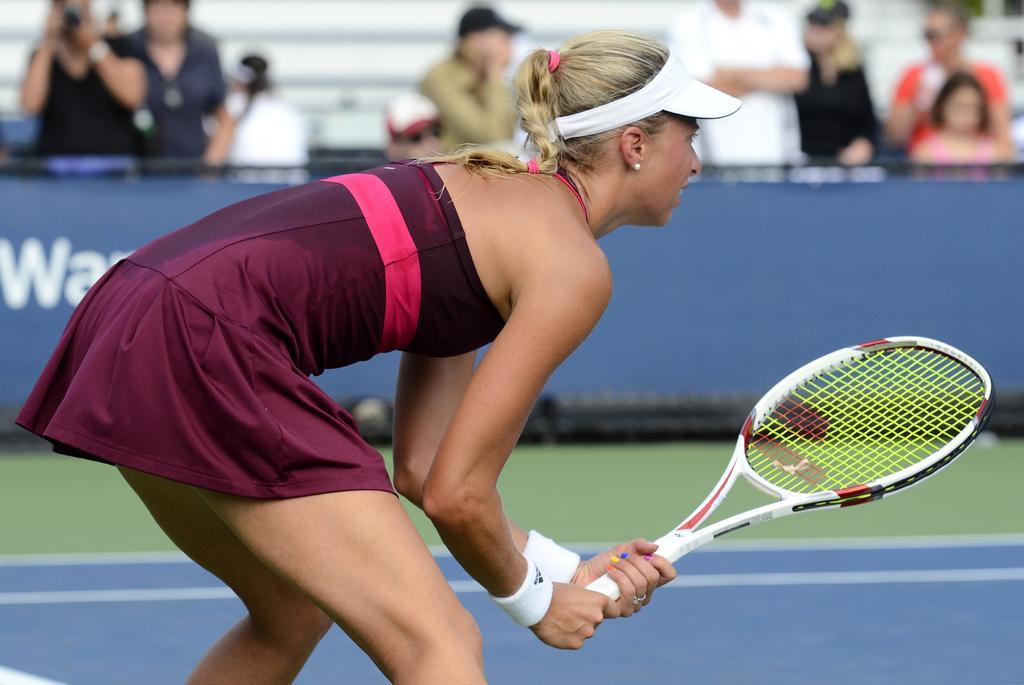Please provide a concise description of this image. In the center of the image there is a woman standing holding a tennis racket in her hands. In the background of the image there are people standing. 